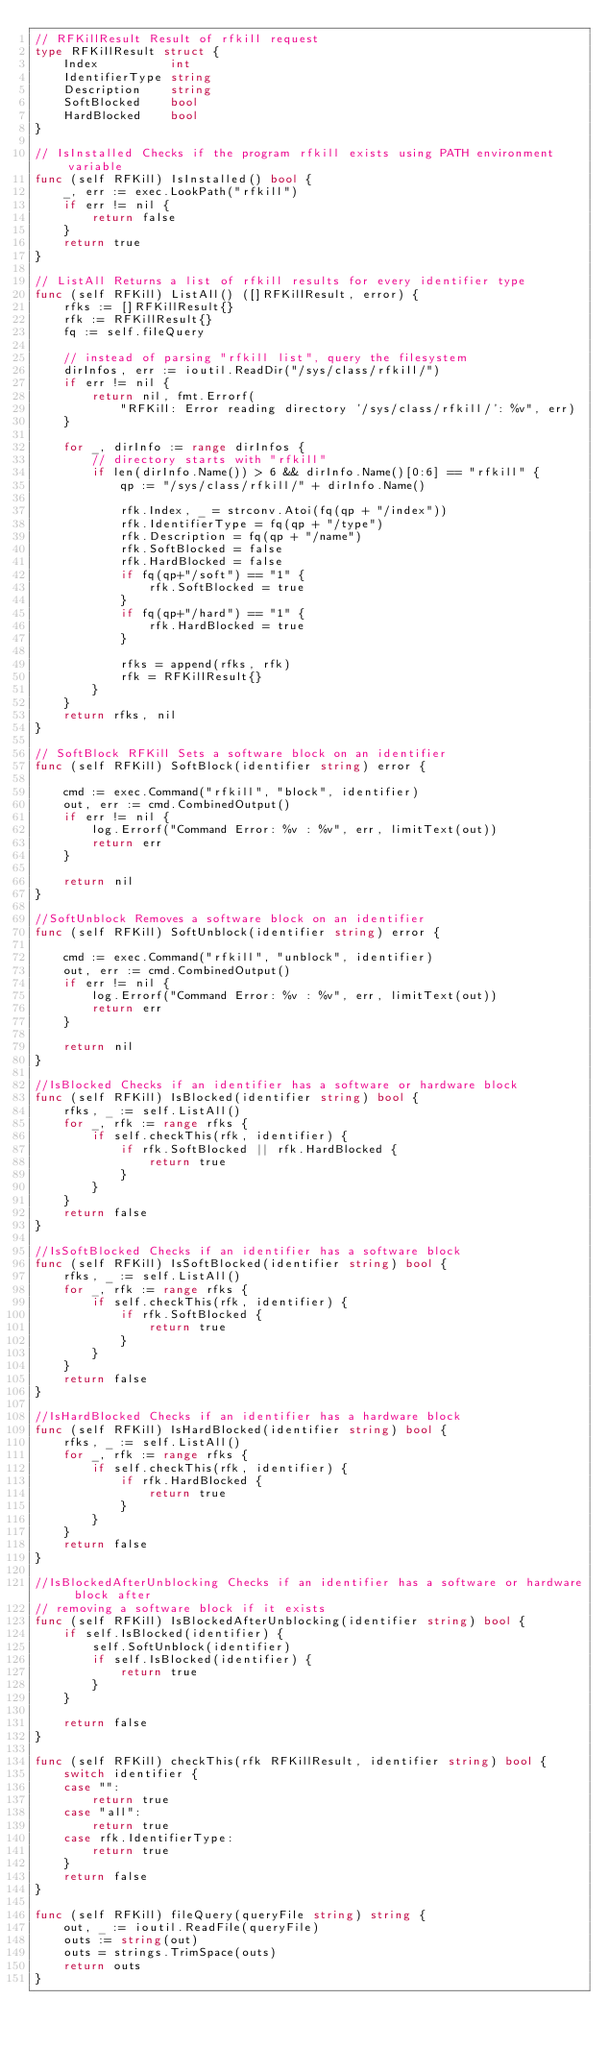<code> <loc_0><loc_0><loc_500><loc_500><_Go_>// RFKillResult Result of rfkill request
type RFKillResult struct {
	Index          int
	IdentifierType string
	Description    string
	SoftBlocked    bool
	HardBlocked    bool
}

// IsInstalled Checks if the program rfkill exists using PATH environment variable
func (self RFKill) IsInstalled() bool {
	_, err := exec.LookPath("rfkill")
	if err != nil {
		return false
	}
	return true
}

// ListAll Returns a list of rfkill results for every identifier type
func (self RFKill) ListAll() ([]RFKillResult, error) {
	rfks := []RFKillResult{}
	rfk := RFKillResult{}
	fq := self.fileQuery

	// instead of parsing "rfkill list", query the filesystem
	dirInfos, err := ioutil.ReadDir("/sys/class/rfkill/")
	if err != nil {
		return nil, fmt.Errorf(
			"RFKill: Error reading directory '/sys/class/rfkill/': %v", err)
	}

	for _, dirInfo := range dirInfos {
		// directory starts with "rfkill"
		if len(dirInfo.Name()) > 6 && dirInfo.Name()[0:6] == "rfkill" {
			qp := "/sys/class/rfkill/" + dirInfo.Name()

			rfk.Index, _ = strconv.Atoi(fq(qp + "/index"))
			rfk.IdentifierType = fq(qp + "/type")
			rfk.Description = fq(qp + "/name")
			rfk.SoftBlocked = false
			rfk.HardBlocked = false
			if fq(qp+"/soft") == "1" {
				rfk.SoftBlocked = true
			}
			if fq(qp+"/hard") == "1" {
				rfk.HardBlocked = true
			}

			rfks = append(rfks, rfk)
			rfk = RFKillResult{}
		}
	}
	return rfks, nil
}

// SoftBlock RFKill Sets a software block on an identifier
func (self RFKill) SoftBlock(identifier string) error {

	cmd := exec.Command("rfkill", "block", identifier)
	out, err := cmd.CombinedOutput()
	if err != nil {
		log.Errorf("Command Error: %v : %v", err, limitText(out))
		return err
	}

	return nil
}

//SoftUnblock Removes a software block on an identifier
func (self RFKill) SoftUnblock(identifier string) error {

	cmd := exec.Command("rfkill", "unblock", identifier)
	out, err := cmd.CombinedOutput()
	if err != nil {
		log.Errorf("Command Error: %v : %v", err, limitText(out))
		return err
	}

	return nil
}

//IsBlocked Checks if an identifier has a software or hardware block
func (self RFKill) IsBlocked(identifier string) bool {
	rfks, _ := self.ListAll()
	for _, rfk := range rfks {
		if self.checkThis(rfk, identifier) {
			if rfk.SoftBlocked || rfk.HardBlocked {
				return true
			}
		}
	}
	return false
}

//IsSoftBlocked Checks if an identifier has a software block
func (self RFKill) IsSoftBlocked(identifier string) bool {
	rfks, _ := self.ListAll()
	for _, rfk := range rfks {
		if self.checkThis(rfk, identifier) {
			if rfk.SoftBlocked {
				return true
			}
		}
	}
	return false
}

//IsHardBlocked Checks if an identifier has a hardware block
func (self RFKill) IsHardBlocked(identifier string) bool {
	rfks, _ := self.ListAll()
	for _, rfk := range rfks {
		if self.checkThis(rfk, identifier) {
			if rfk.HardBlocked {
				return true
			}
		}
	}
	return false
}

//IsBlockedAfterUnblocking Checks if an identifier has a software or hardware block after
// removing a software block if it exists
func (self RFKill) IsBlockedAfterUnblocking(identifier string) bool {
	if self.IsBlocked(identifier) {
		self.SoftUnblock(identifier)
		if self.IsBlocked(identifier) {
			return true
		}
	}

	return false
}

func (self RFKill) checkThis(rfk RFKillResult, identifier string) bool {
	switch identifier {
	case "":
		return true
	case "all":
		return true
	case rfk.IdentifierType:
		return true
	}
	return false
}

func (self RFKill) fileQuery(queryFile string) string {
	out, _ := ioutil.ReadFile(queryFile)
	outs := string(out)
	outs = strings.TrimSpace(outs)
	return outs
}
</code> 